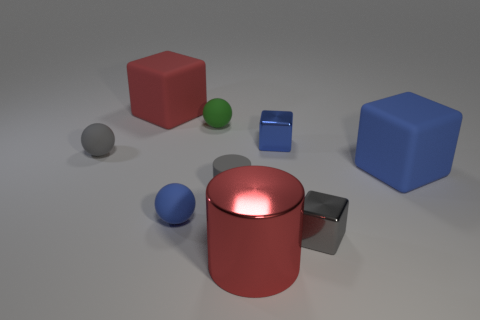There is a large rubber object that is on the right side of the small gray metal object; what color is it?
Keep it short and to the point. Blue. There is a object left of the big thing that is behind the small blue metal cube; are there any red objects behind it?
Provide a short and direct response. Yes. Are there more big matte blocks in front of the blue shiny cube than yellow matte blocks?
Provide a short and direct response. Yes. Is the shape of the big thing that is on the right side of the tiny gray metal block the same as  the large red rubber thing?
Ensure brevity in your answer.  Yes. What number of objects are small red spheres or cubes left of the red cylinder?
Offer a terse response. 1. What size is the blue object that is in front of the small blue block and on the right side of the red metal cylinder?
Your answer should be very brief. Large. Is the number of big blue things that are behind the large red cube greater than the number of gray matte balls to the right of the green matte sphere?
Keep it short and to the point. No. Do the tiny blue rubber object and the tiny green thing on the left side of the big red metal cylinder have the same shape?
Your response must be concise. Yes. What number of other objects are the same shape as the tiny green rubber thing?
Make the answer very short. 2. What is the color of the rubber thing that is both right of the green matte thing and on the left side of the large metal thing?
Provide a succinct answer. Gray. 